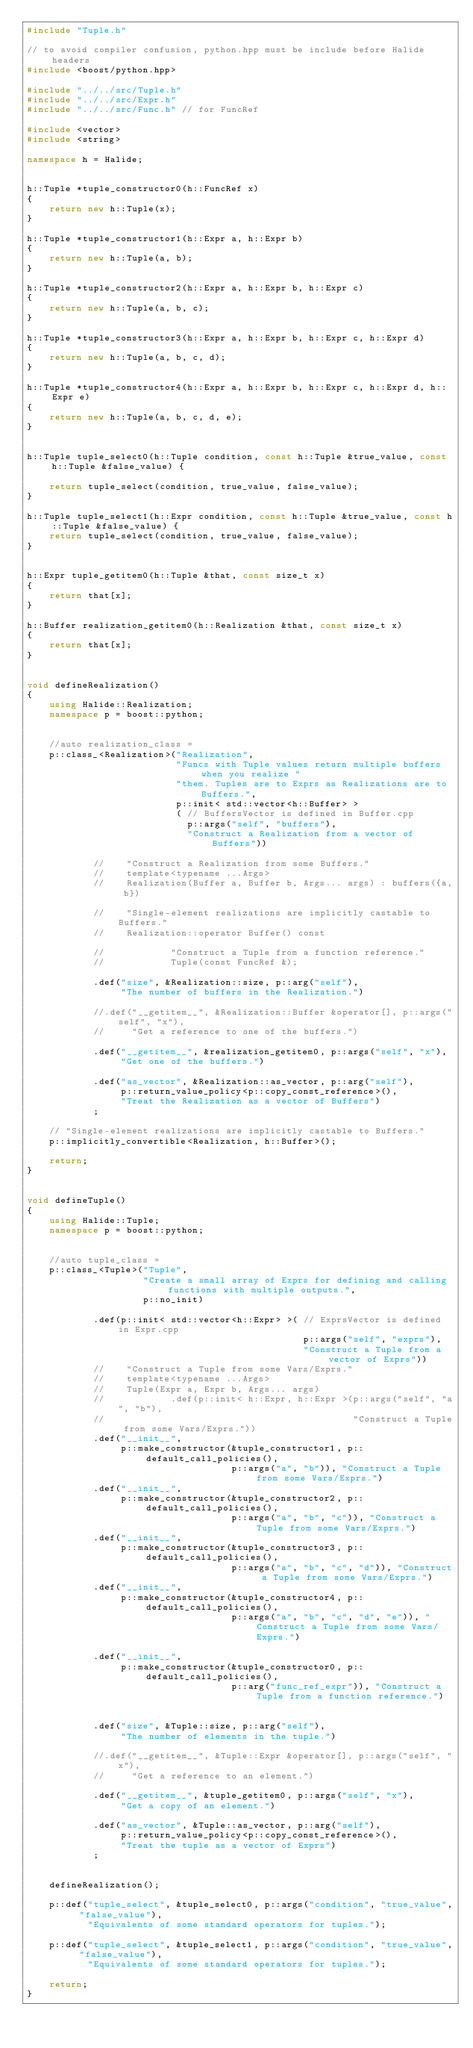<code> <loc_0><loc_0><loc_500><loc_500><_C++_>#include "Tuple.h"

// to avoid compiler confusion, python.hpp must be include before Halide headers
#include <boost/python.hpp>

#include "../../src/Tuple.h"
#include "../../src/Expr.h"
#include "../../src/Func.h" // for FuncRef

#include <vector>
#include <string>

namespace h = Halide;


h::Tuple *tuple_constructor0(h::FuncRef x)
{
    return new h::Tuple(x);
}

h::Tuple *tuple_constructor1(h::Expr a, h::Expr b)
{
    return new h::Tuple(a, b);
}

h::Tuple *tuple_constructor2(h::Expr a, h::Expr b, h::Expr c)
{
    return new h::Tuple(a, b, c);
}

h::Tuple *tuple_constructor3(h::Expr a, h::Expr b, h::Expr c, h::Expr d)
{
    return new h::Tuple(a, b, c, d);
}

h::Tuple *tuple_constructor4(h::Expr a, h::Expr b, h::Expr c, h::Expr d, h::Expr e)
{
    return new h::Tuple(a, b, c, d, e);
}


h::Tuple tuple_select0(h::Tuple condition, const h::Tuple &true_value, const h::Tuple &false_value) {

    return tuple_select(condition, true_value, false_value);
}

h::Tuple tuple_select1(h::Expr condition, const h::Tuple &true_value, const h::Tuple &false_value) {
    return tuple_select(condition, true_value, false_value);
}


h::Expr tuple_getitem0(h::Tuple &that, const size_t x)
{
    return that[x];
}

h::Buffer realization_getitem0(h::Realization &that, const size_t x)
{
    return that[x];
}


void defineRealization()
{
    using Halide::Realization;
    namespace p = boost::python;


    //auto realization_class =
    p::class_<Realization>("Realization",
                           "Funcs with Tuple values return multiple buffers when you realize "
                           "them. Tuples are to Exprs as Realizations are to Buffers.",
                           p::init< std::vector<h::Buffer> >
                           ( // BuffersVector is defined in Buffer.cpp
                             p::args("self", "buffers"),
                             "Construct a Realization from a vector of Buffers"))

            //    "Construct a Realization from some Buffers."
            //    template<typename ...Args>
            //    Realization(Buffer a, Buffer b, Args... args) : buffers({a, b})

            //    "Single-element realizations are implicitly castable to Buffers."
            //    Realization::operator Buffer() const

            //            "Construct a Tuple from a function reference."
            //            Tuple(const FuncRef &);

            .def("size", &Realization::size, p::arg("self"),
                 "The number of buffers in the Realization.")

            //.def("__getitem__", &Realization::Buffer &operator[], p::args("self", "x"),
            //     "Get a reference to one of the buffers.")

            .def("__getitem__", &realization_getitem0, p::args("self", "x"),
                 "Get one of the buffers.")

            .def("as_vector", &Realization::as_vector, p::arg("self"),
                 p::return_value_policy<p::copy_const_reference>(),
                 "Treat the Realization as a vector of Buffers")
            ;

    // "Single-element realizations are implicitly castable to Buffers."
    p::implicitly_convertible<Realization, h::Buffer>();

    return;
}


void defineTuple()
{
    using Halide::Tuple;
    namespace p = boost::python;


    //auto tuple_class =
    p::class_<Tuple>("Tuple",
                     "Create a small array of Exprs for defining and calling functions with multiple outputs.",
                     p::no_init)

            .def(p::init< std::vector<h::Expr> >( // ExprsVector is defined in Expr.cpp
                                                  p::args("self", "exprs"),
                                                  "Construct a Tuple from a vector of Exprs"))
            //    "Construct a Tuple from some Vars/Exprs."
            //    template<typename ...Args>
            //    Tuple(Expr a, Expr b, Args... args)
            //            .def(p::init< h::Expr, h::Expr >(p::args("self", "a", "b"),
            //                                             "Construct a Tuple from some Vars/Exprs."))
            .def("__init__",
                 p::make_constructor(&tuple_constructor1, p::default_call_policies(),
                                     p::args("a", "b")), "Construct a Tuple from some Vars/Exprs.")
            .def("__init__",
                 p::make_constructor(&tuple_constructor2, p::default_call_policies(),
                                     p::args("a", "b", "c")), "Construct a Tuple from some Vars/Exprs.")
            .def("__init__",
                 p::make_constructor(&tuple_constructor3, p::default_call_policies(),
                                     p::args("a", "b", "c", "d")), "Construct a Tuple from some Vars/Exprs.")
            .def("__init__",
                 p::make_constructor(&tuple_constructor4, p::default_call_policies(),
                                     p::args("a", "b", "c", "d", "e")), "Construct a Tuple from some Vars/Exprs.")

            .def("__init__",
                 p::make_constructor(&tuple_constructor0, p::default_call_policies(),
                                     p::arg("func_ref_expr")), "Construct a Tuple from a function reference.")


            .def("size", &Tuple::size, p::arg("self"),
                 "The number of elements in the tuple.")

            //.def("__getitem__", &Tuple::Expr &operator[], p::args("self", "x"),
            //     "Get a reference to an element.")

            .def("__getitem__", &tuple_getitem0, p::args("self", "x"),
                 "Get a copy of an element.")

            .def("as_vector", &Tuple::as_vector, p::arg("self"),
                 p::return_value_policy<p::copy_const_reference>(),
                 "Treat the tuple as a vector of Exprs")
            ;


    defineRealization();

    p::def("tuple_select", &tuple_select0, p::args("condition", "true_value", "false_value"),
           "Equivalents of some standard operators for tuples.");

    p::def("tuple_select", &tuple_select1, p::args("condition", "true_value", "false_value"),
           "Equivalents of some standard operators for tuples.");

    return;
}</code> 